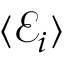Convert formula to latex. <formula><loc_0><loc_0><loc_500><loc_500>\langle { \mathcal { E } } _ { i } \rangle</formula> 